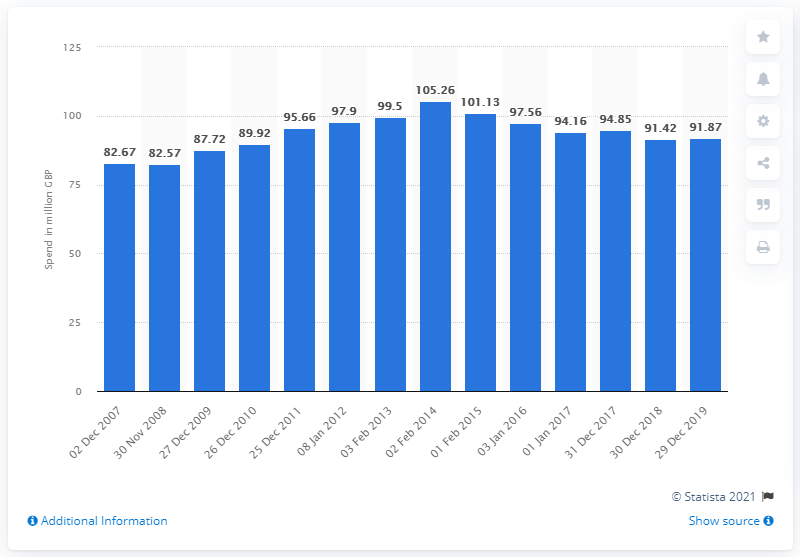Specify some key components in this picture. In the 52-week period ending December 29th, 2019, 91.87 British pounds were spent on chilled pate, paste, and spread. 